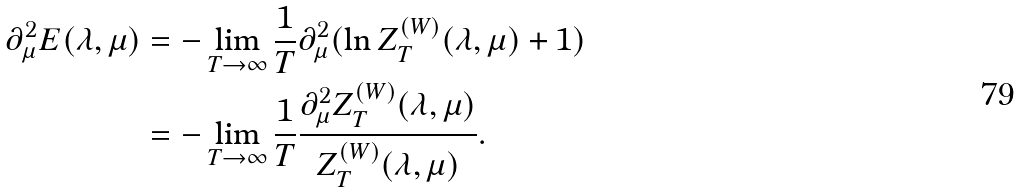Convert formula to latex. <formula><loc_0><loc_0><loc_500><loc_500>\partial _ { \mu } ^ { 2 } E ( \lambda , \mu ) & = - \lim _ { T \to \infty } \frac { 1 } { T } \partial _ { \mu } ^ { 2 } ( \ln Z ^ { ( W ) } _ { T } ( \lambda , \mu ) + 1 ) \\ & = - \lim _ { T \to \infty } \frac { 1 } { T } \frac { \partial _ { \mu } ^ { 2 } Z ^ { ( W ) } _ { T } ( \lambda , \mu ) } { Z ^ { ( W ) } _ { T } ( \lambda , \mu ) } .</formula> 